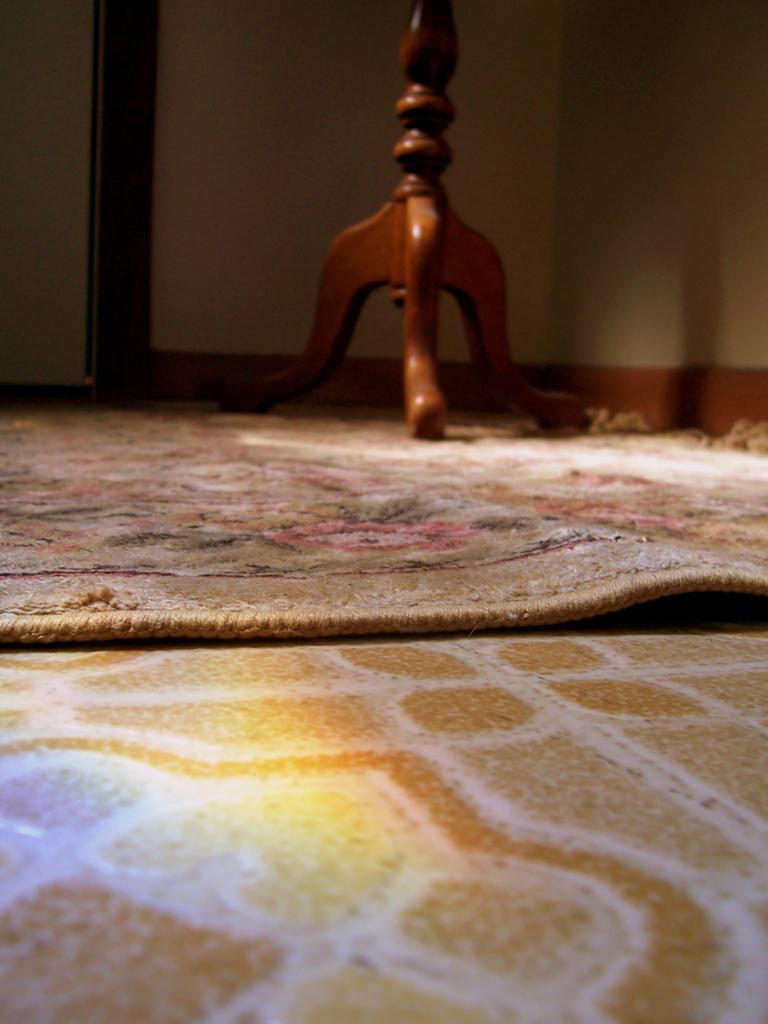Where was the image taken? The image was taken indoors. What can be seen in the foreground of the image? There is a floor visible in the foreground. What is placed on the floor in the image? There is a floor mat on the floor. What can be seen in the background of the image? There is a wall in the background. What type of object is placed on the ground in the background? There is a wooden object placed on the ground in the background. How many geese are visible on the floor mat in the image? There are no geese present in the image. What type of key is used to unlock the wooden object in the image? There is no key or locking mechanism present on the wooden object in the image. 